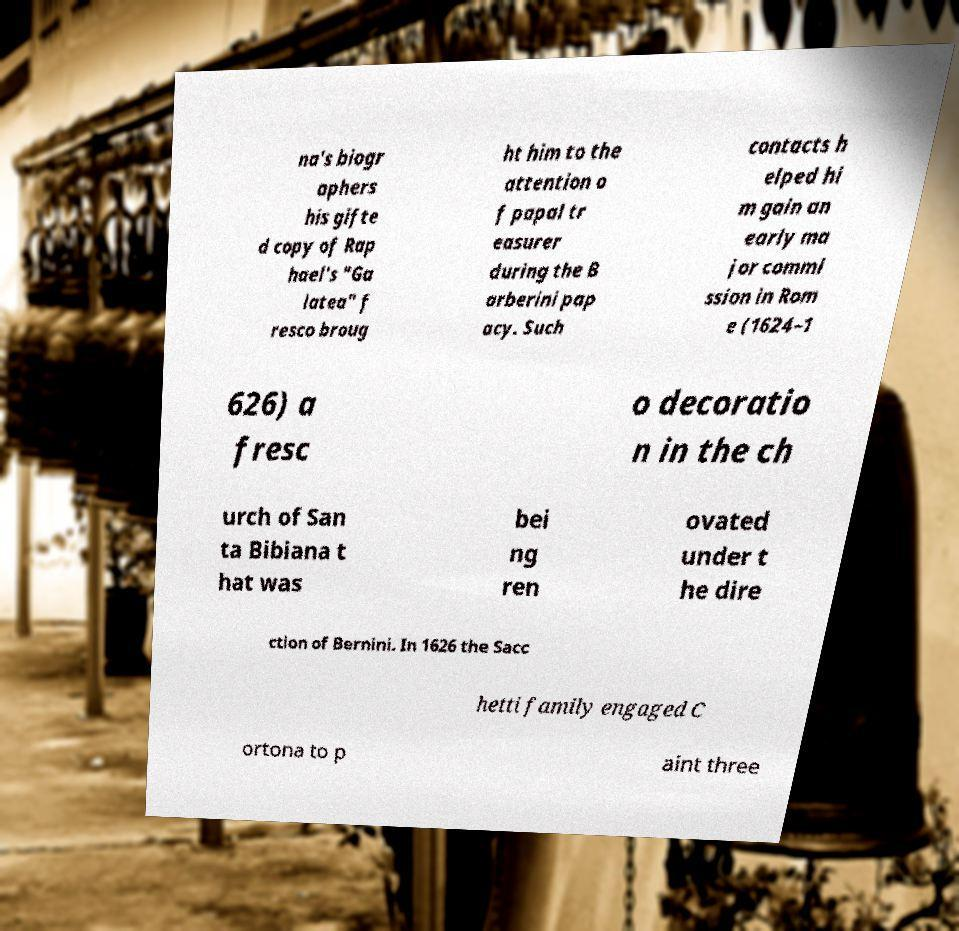There's text embedded in this image that I need extracted. Can you transcribe it verbatim? na's biogr aphers his gifte d copy of Rap hael's "Ga latea" f resco broug ht him to the attention o f papal tr easurer during the B arberini pap acy. Such contacts h elped hi m gain an early ma jor commi ssion in Rom e (1624–1 626) a fresc o decoratio n in the ch urch of San ta Bibiana t hat was bei ng ren ovated under t he dire ction of Bernini. In 1626 the Sacc hetti family engaged C ortona to p aint three 